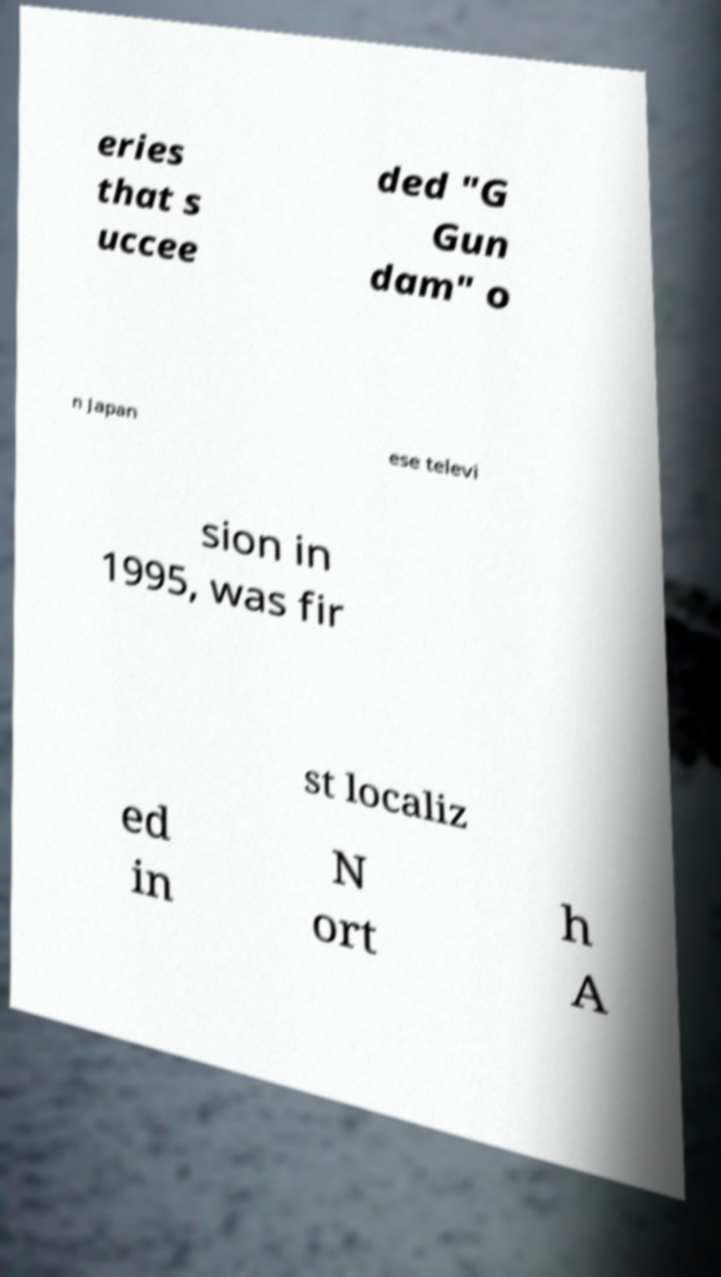Please read and relay the text visible in this image. What does it say? eries that s uccee ded "G Gun dam" o n Japan ese televi sion in 1995, was fir st localiz ed in N ort h A 